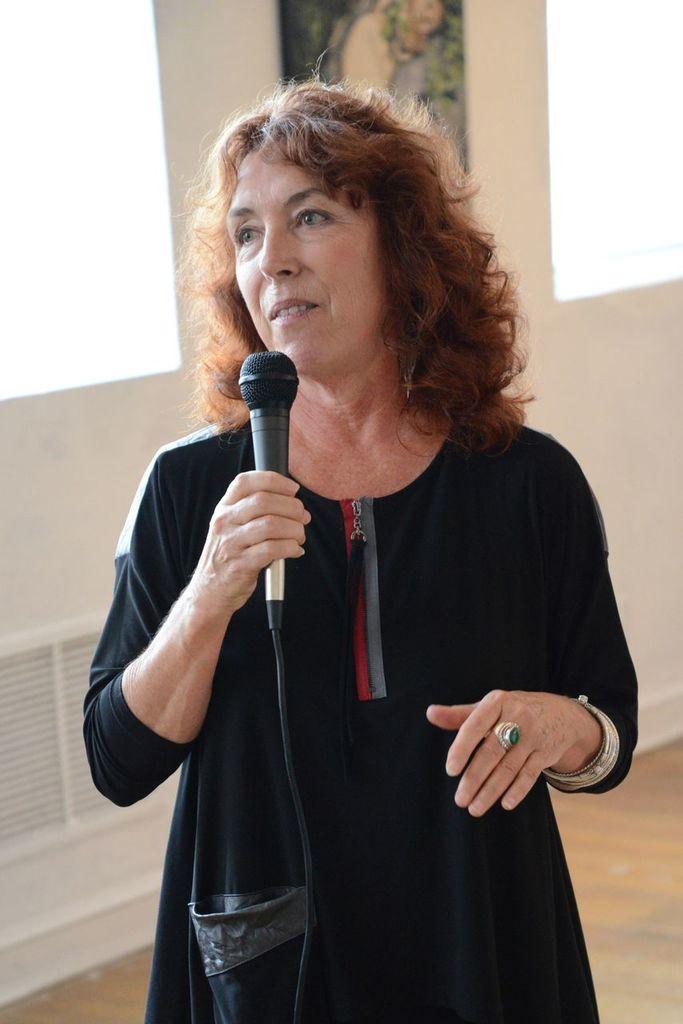In one or two sentences, can you explain what this image depicts? In this image we can see a woman standing on the floor and holding a mic in one of her hands. In the background there is a wall. 